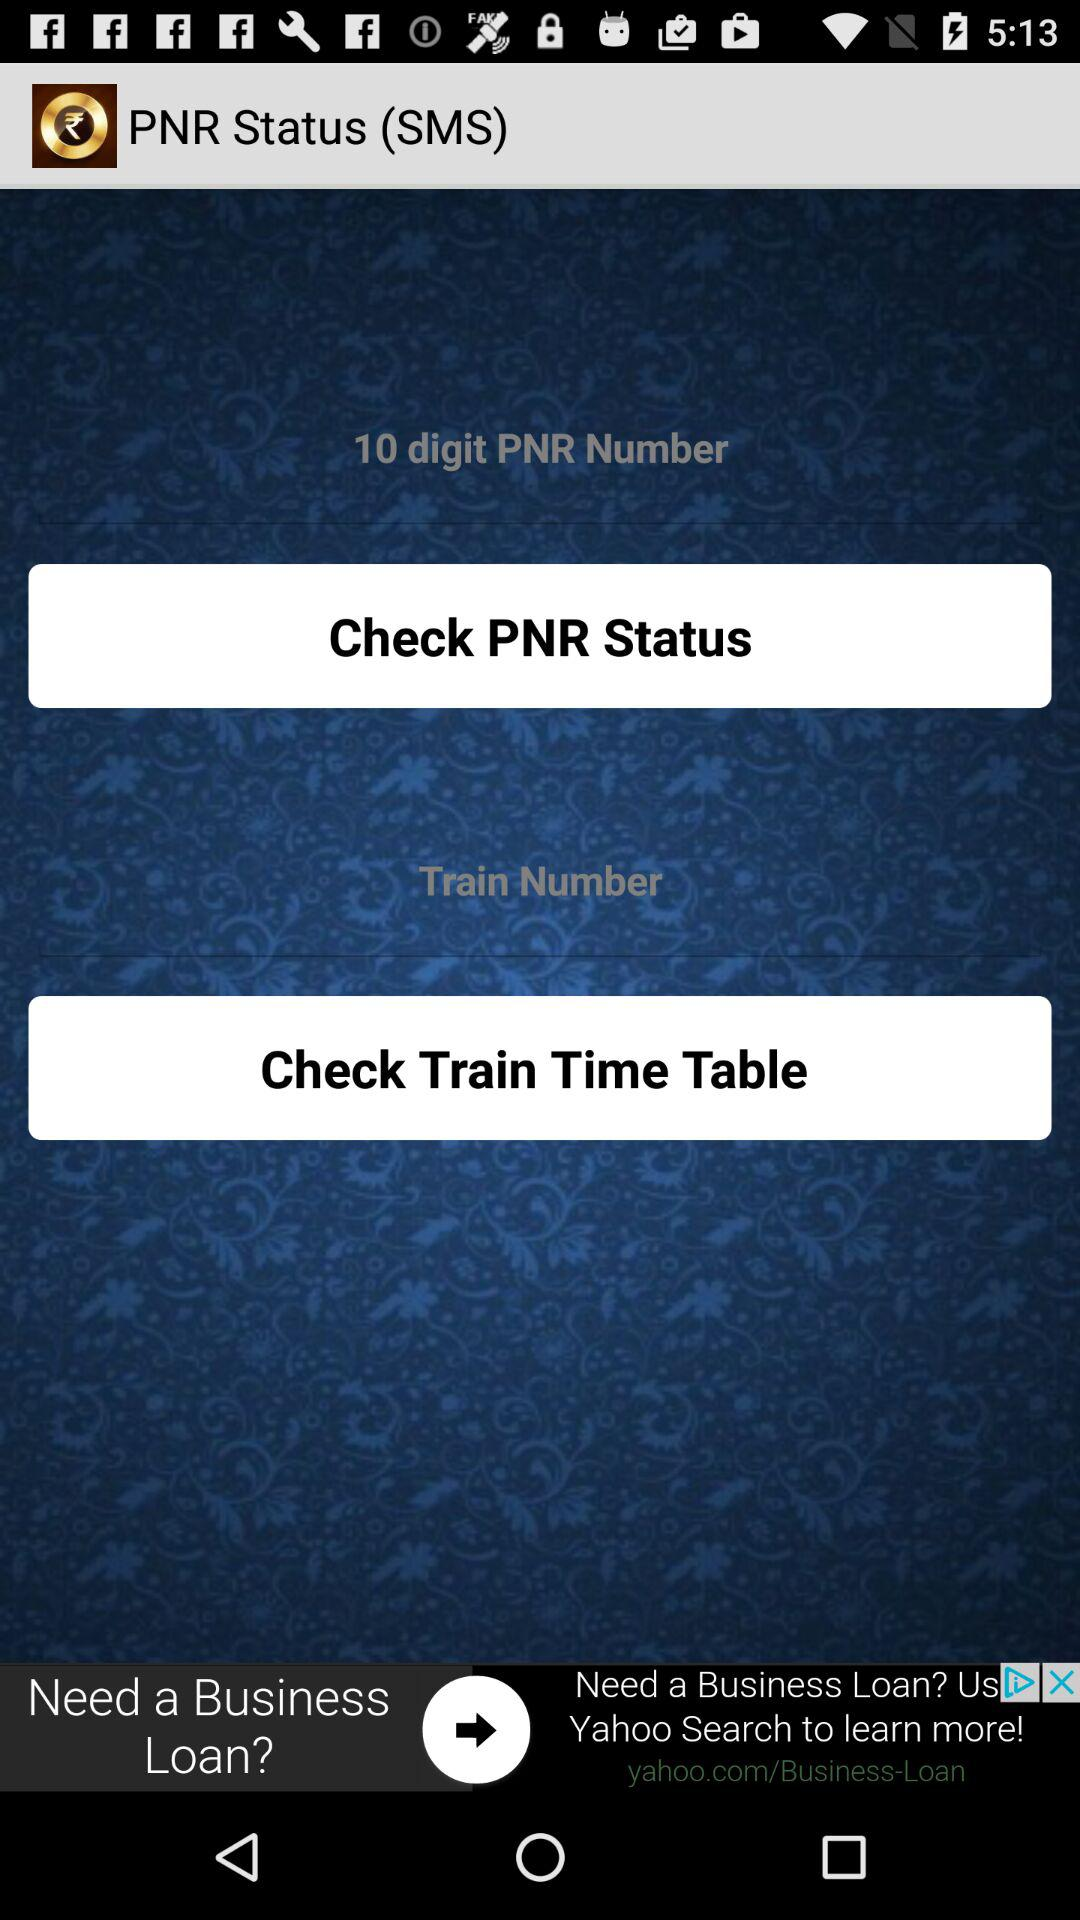How many digits are there in the PNR number? There are 10 digits in the PNR number. 